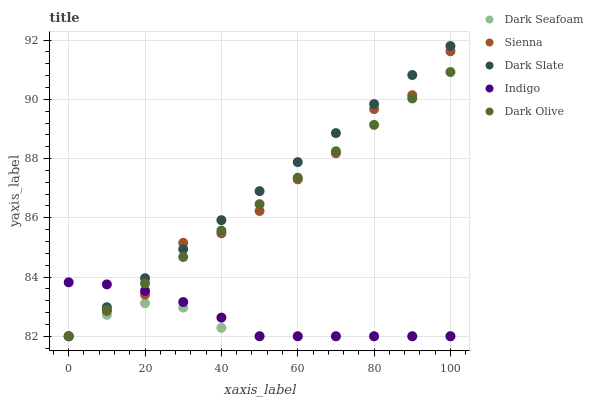Does Dark Seafoam have the minimum area under the curve?
Answer yes or no. Yes. Does Dark Slate have the maximum area under the curve?
Answer yes or no. Yes. Does Dark Slate have the minimum area under the curve?
Answer yes or no. No. Does Dark Seafoam have the maximum area under the curve?
Answer yes or no. No. Is Dark Slate the smoothest?
Answer yes or no. Yes. Is Sienna the roughest?
Answer yes or no. Yes. Is Dark Seafoam the smoothest?
Answer yes or no. No. Is Dark Seafoam the roughest?
Answer yes or no. No. Does Sienna have the lowest value?
Answer yes or no. Yes. Does Dark Slate have the highest value?
Answer yes or no. Yes. Does Dark Seafoam have the highest value?
Answer yes or no. No. Does Indigo intersect Dark Seafoam?
Answer yes or no. Yes. Is Indigo less than Dark Seafoam?
Answer yes or no. No. Is Indigo greater than Dark Seafoam?
Answer yes or no. No. 